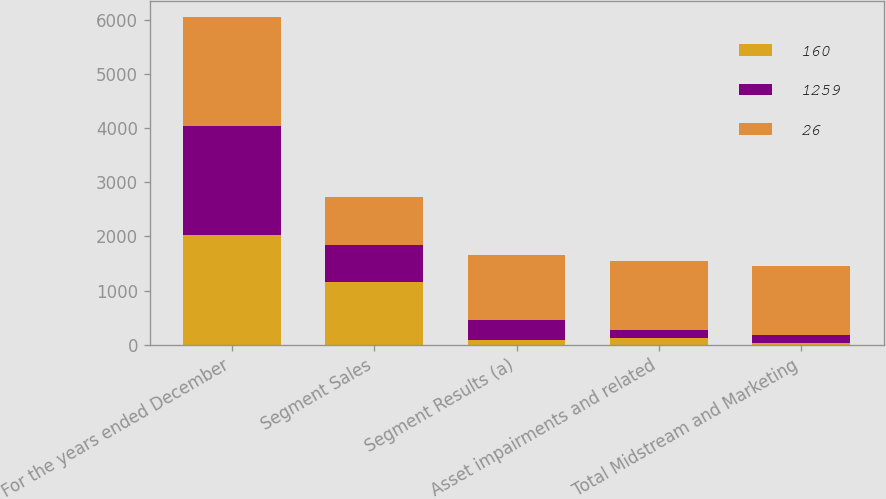Convert chart to OTSL. <chart><loc_0><loc_0><loc_500><loc_500><stacked_bar_chart><ecel><fcel>For the years ended December<fcel>Segment Sales<fcel>Segment Results (a)<fcel>Asset impairments and related<fcel>Total Midstream and Marketing<nl><fcel>160<fcel>2017<fcel>1157<fcel>85<fcel>120<fcel>26<nl><fcel>1259<fcel>2016<fcel>684<fcel>381<fcel>160<fcel>160<nl><fcel>26<fcel>2015<fcel>891<fcel>1194<fcel>1259<fcel>1259<nl></chart> 